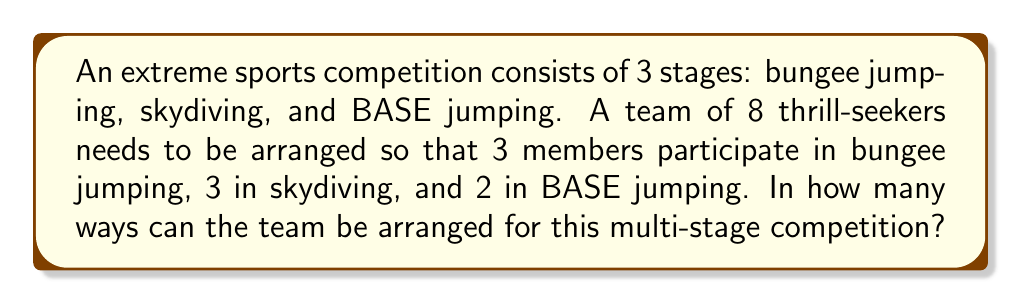Show me your answer to this math problem. Let's approach this step-by-step:

1) First, we need to choose which team members will participate in each stage. This is a combination problem.

2) For bungee jumping, we need to choose 3 out of 8 people:
   $${8 \choose 3} = \frac{8!}{3!(8-3)!} = \frac{8!}{3!5!} = 56$$

3) After selecting 3 for bungee jumping, we have 5 people left. From these, we need to choose 3 for skydiving:
   $${5 \choose 3} = \frac{5!}{3!(5-3)!} = \frac{5!}{3!2!} = 10$$

4) The remaining 2 people will automatically be assigned to BASE jumping.

5) Now, we apply the multiplication principle. The total number of ways to arrange the team is:
   $$56 \times 10 = 560$$

This gives us the number of ways to assign people to each stage, but we're not done yet.

6) For each stage, the order of participants matters (as they might jump in a specific order). So we need to consider permutations within each stage:
   - Bungee jumping: 3! = 6 ways
   - Skydiving: 3! = 6 ways
   - BASE jumping: 2! = 2 ways

7) Applying the multiplication principle again, the final number of arrangements is:
   $$560 \times 6 \times 6 \times 2 = 40,320$$
Answer: 40,320 